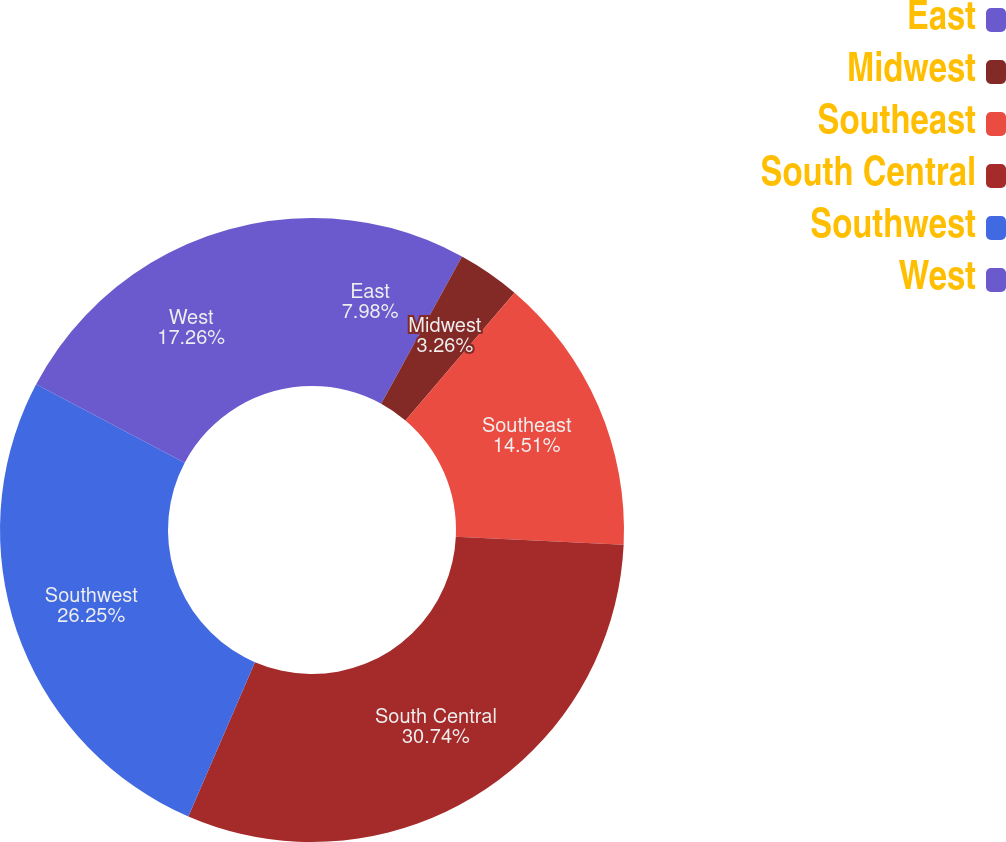Convert chart. <chart><loc_0><loc_0><loc_500><loc_500><pie_chart><fcel>East<fcel>Midwest<fcel>Southeast<fcel>South Central<fcel>Southwest<fcel>West<nl><fcel>7.98%<fcel>3.26%<fcel>14.51%<fcel>30.73%<fcel>26.25%<fcel>17.26%<nl></chart> 